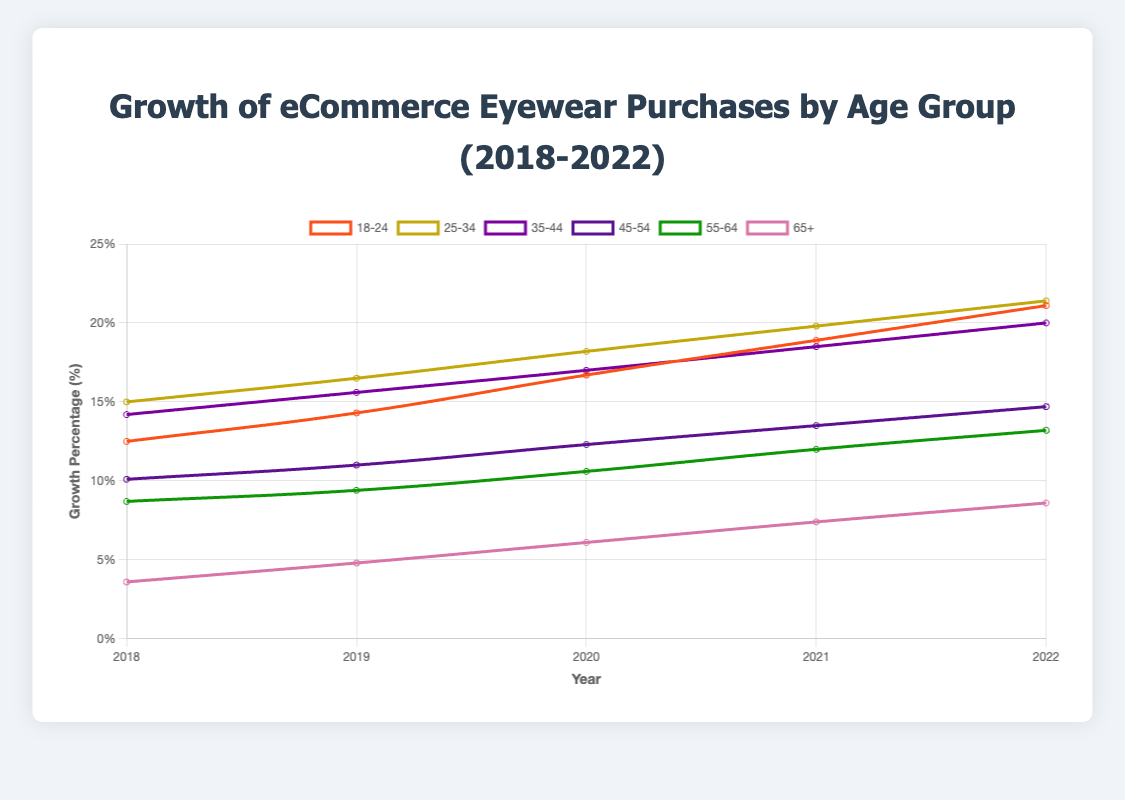What was the average growth percentage for the 18-24 age group between 2018 and 2022? Calculate the sum of the growth percentages for the 18-24 age group over the years 2018 to 2022, which is (12.5 + 14.3 + 16.7 + 18.9 + 21.1) = 83.5. Then, divide by the number of years (5). The average is 83.5 / 5 = 16.7.
Answer: 16.7% Which age group had the highest growth percentage in 2022? For the year 2022, compare the growth percentages of all age groups: 18-24: 21.1%, 25-34: 21.4%, 35-44: 20.0%, 45-54: 14.7%, 55-64: 13.2%, 65+: 8.6%. The highest value is 21.4% for the 25-34 age group.
Answer: 25-34 By how much did the growth percentage of the 65+ age group increase from 2018 to 2022? Subtract the growth percentage of the 65+ age group in 2018 (3.6%) from its growth percentage in 2022 (8.6%). The increase is 8.6% - 3.6% = 5.0%.
Answer: 5.0% What is the total growth percentage for all age groups combined in the year 2020? Sum all the growth percentages for 2020: 16.7% (18-24) + 18.2% (25-34) + 17.0% (35-44) + 12.3% (45-54) + 10.6% (55-64) + 6.1% (65+). The total is 80.9%.
Answer: 80.9% How does the growth rate of the 55-64 age group in 2021 compare to that of the 18-24 age group in the same year? The growth rate of the 55-64 age group in 2021 is 12.0%, while the 18-24 age group is 18.9%. The 18-24 age group had a higher growth rate than the 55-64 age group in 2021.
Answer: 18.9% is higher What was the overall trend for the 25-34 age group from 2018 to 2022? Observing the growth percentages for the 25-34 age group over the years: 15.0% (2018), 16.5% (2019), 18.2% (2020), 19.8% (2021), 21.4% (2022), we see a steadily increasing trend each year, meaning consistent growth over time.
Answer: Increasing What is the combined growth rate difference between the youngest (18-24) and oldest (65+) age groups in 2022? Subtract the growth percentage of the 65+ age group (8.6%) from the growth percentage of the 18-24 age group (21.1%) in 2022. The difference is 21.1% - 8.6% = 12.5%.
Answer: 12.5% 